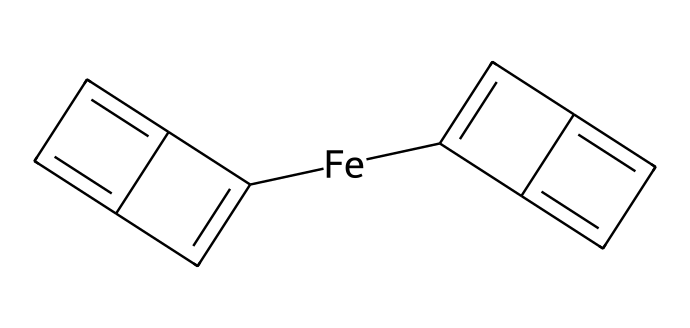How many carbon atoms are present in ferrocene? To determine the number of carbon atoms, we examine the SMILES representation, where 'C' represents carbon. Counting the 'C' elements gives us five carbon atoms in the entire structure.
Answer: five What is the central metal atom in ferrocene? The central atom in the given chemical structure is identified as 'Fe', which is the symbol for iron.
Answer: iron How many rings are present in the structure of ferrocene? Observing the molecular structure depicted in the SMILES, there are two cyclopentadienyl rings that encircle the iron atom, thus making a total of two rings present.
Answer: two What is the hybridization state of the iron atom in ferrocene? The hybridization of the iron atom can be inferred from its coordination within the structure. In ferrocene, iron is bonded to two cyclopentadienyl anions, leading to a sp2 hybridization state.
Answer: sp2 Which type of interaction primarily stabilizes the structure of ferrocene? Ferrocene's structure is primarily stabilized by the metal-carbon (M-C) bond interactions between the iron atom and the carbon atoms of the cyclopentadienyl rings, which are examples of coordinate covalent bonding.
Answer: coordinate covalent bonding How many π bonds are present in the structure of ferrocene? The π bonds can be identified in each cyclopentadienyl ring. Each ring contains four π bonds due to the alternating double bonds, leading to a total of four π bonds in each ring, summing to eight π bonds overall.
Answer: eight What type of organometallic compound is represented by ferrocene? Ferrocene is classified as a metallocene, characterized by its sandwich-like structure, with the metal (iron) situated between two π-accepting cyclopentadienyl ligands.
Answer: metallocene 